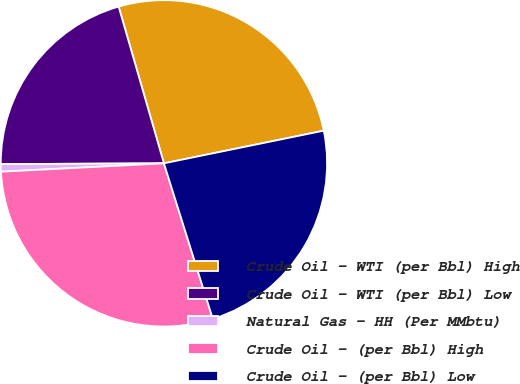Convert chart to OTSL. <chart><loc_0><loc_0><loc_500><loc_500><pie_chart><fcel>Crude Oil - WTI (per Bbl) High<fcel>Crude Oil - WTI (per Bbl) Low<fcel>Natural Gas - HH (Per MMbtu)<fcel>Crude Oil - (per Bbl) High<fcel>Crude Oil - (per Bbl) Low<nl><fcel>26.27%<fcel>20.6%<fcel>0.74%<fcel>29.03%<fcel>23.36%<nl></chart> 